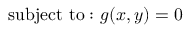<formula> <loc_0><loc_0><loc_500><loc_500>{ s u b j e c t t o \colon } \ g ( x , y ) = 0</formula> 